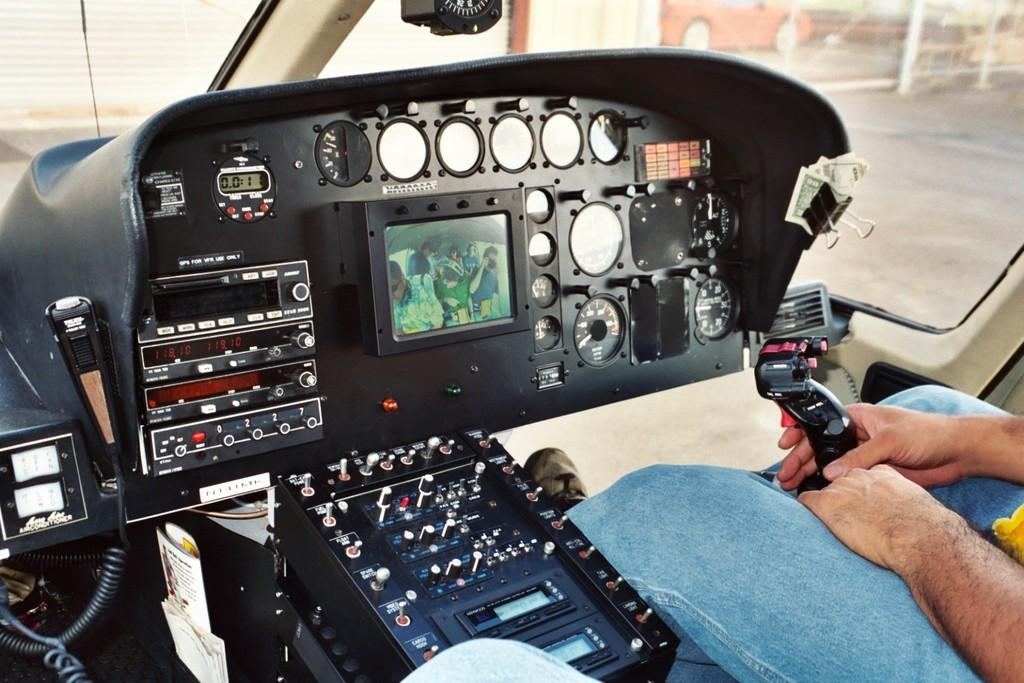What can be seen in the image, despite it being a truncated picture? There is a person in the image, wearing clothes and shoes. What type of setting is depicted in the image? The image shows an internal view of a vehicle. What part of the vehicle is visible in the image? The floor is visible in the image. Where is the bat hanging in the image? There is no bat present in the image; it only shows a person in a vehicle. What type of lunchroom can be seen in the image? There is no lunchroom present in the image; it depicts an internal view of a vehicle. 